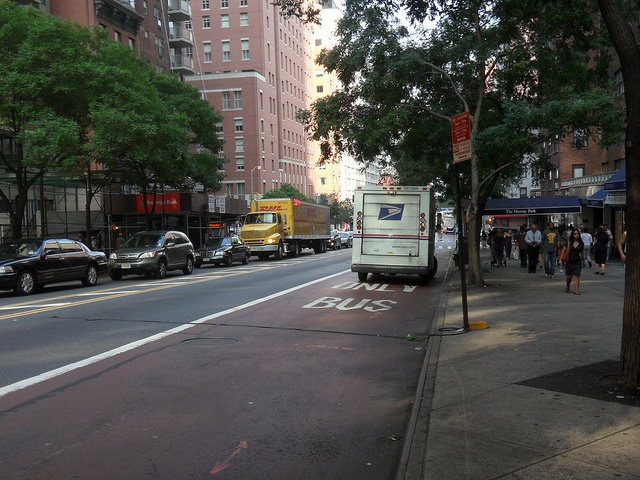Describe the objects in this image and their specific colors. I can see truck in darkgreen, darkgray, black, gray, and lightgray tones, truck in darkgreen, gray, black, olive, and darkgray tones, car in darkgreen, black, gray, darkgray, and lightblue tones, car in darkgreen, black, gray, darkgray, and lightgray tones, and car in darkgreen, black, gray, and darkgray tones in this image. 